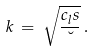Convert formula to latex. <formula><loc_0><loc_0><loc_500><loc_500>k \, = \, \sqrt { \frac { c _ { l } s } { \lambda } } \, .</formula> 